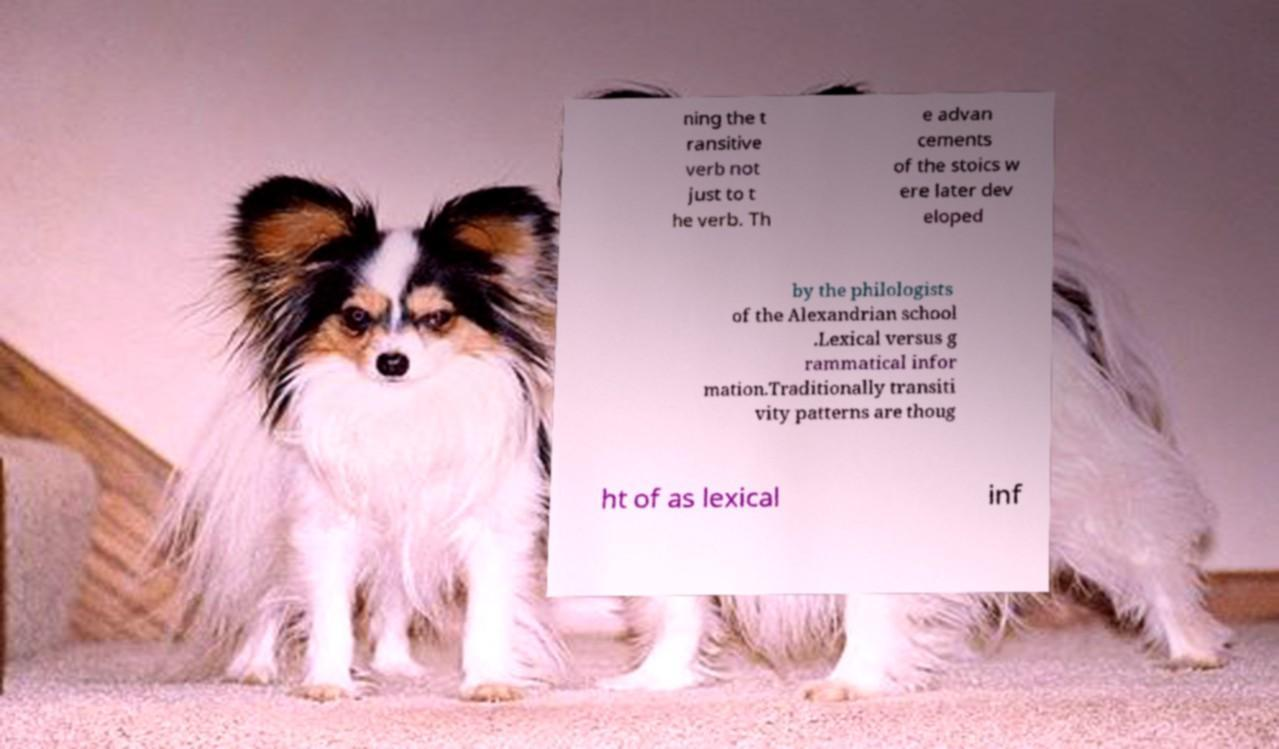I need the written content from this picture converted into text. Can you do that? ning the t ransitive verb not just to t he verb. Th e advan cements of the stoics w ere later dev eloped by the philologists of the Alexandrian school .Lexical versus g rammatical infor mation.Traditionally transiti vity patterns are thoug ht of as lexical inf 